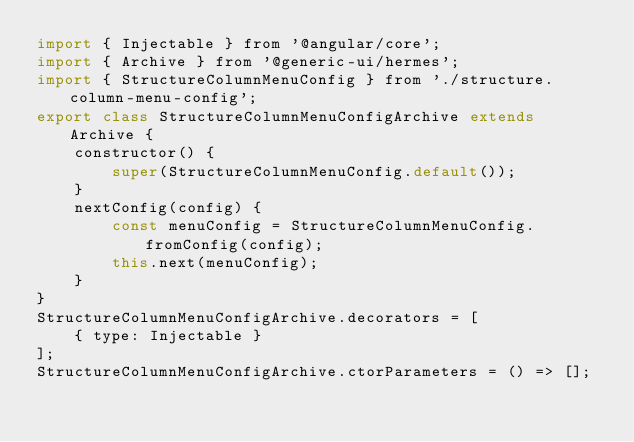<code> <loc_0><loc_0><loc_500><loc_500><_JavaScript_>import { Injectable } from '@angular/core';
import { Archive } from '@generic-ui/hermes';
import { StructureColumnMenuConfig } from './structure.column-menu-config';
export class StructureColumnMenuConfigArchive extends Archive {
    constructor() {
        super(StructureColumnMenuConfig.default());
    }
    nextConfig(config) {
        const menuConfig = StructureColumnMenuConfig.fromConfig(config);
        this.next(menuConfig);
    }
}
StructureColumnMenuConfigArchive.decorators = [
    { type: Injectable }
];
StructureColumnMenuConfigArchive.ctorParameters = () => [];</code> 